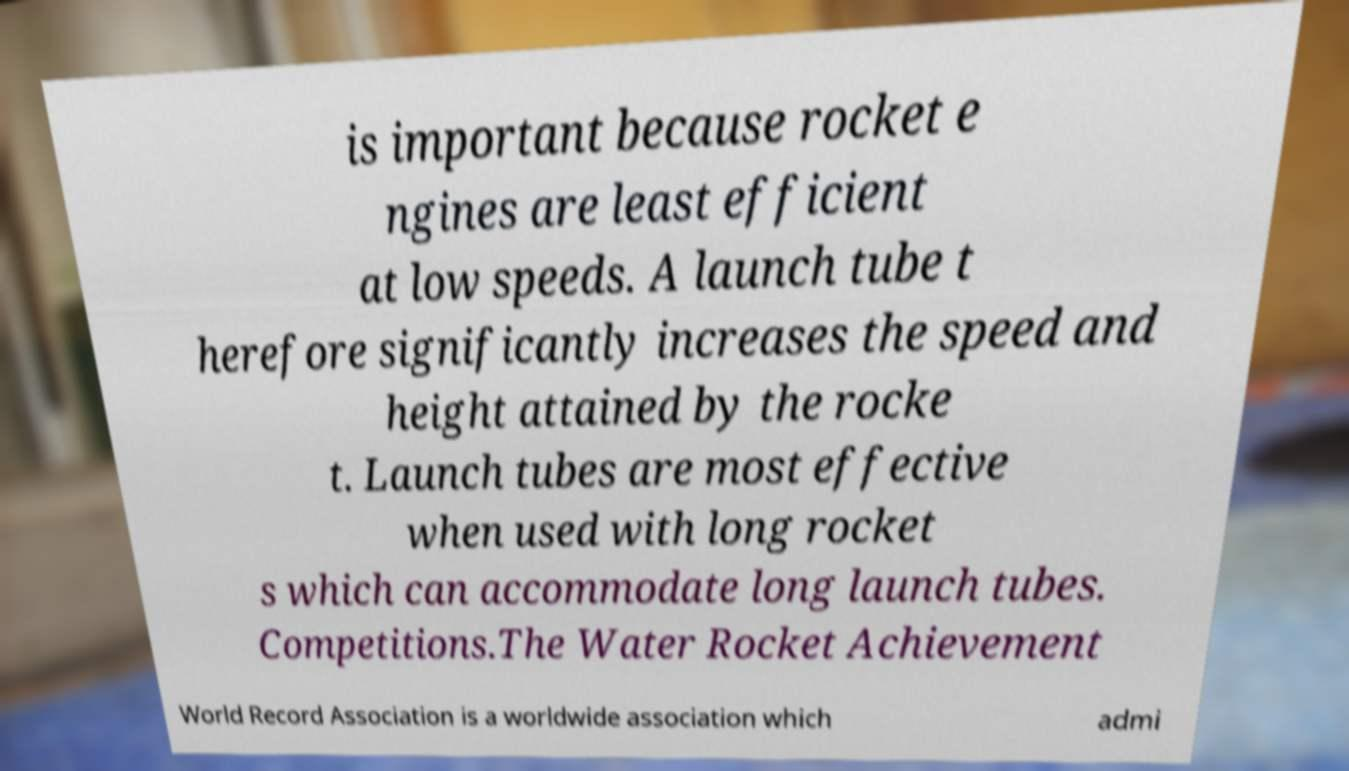Please read and relay the text visible in this image. What does it say? is important because rocket e ngines are least efficient at low speeds. A launch tube t herefore significantly increases the speed and height attained by the rocke t. Launch tubes are most effective when used with long rocket s which can accommodate long launch tubes. Competitions.The Water Rocket Achievement World Record Association is a worldwide association which admi 